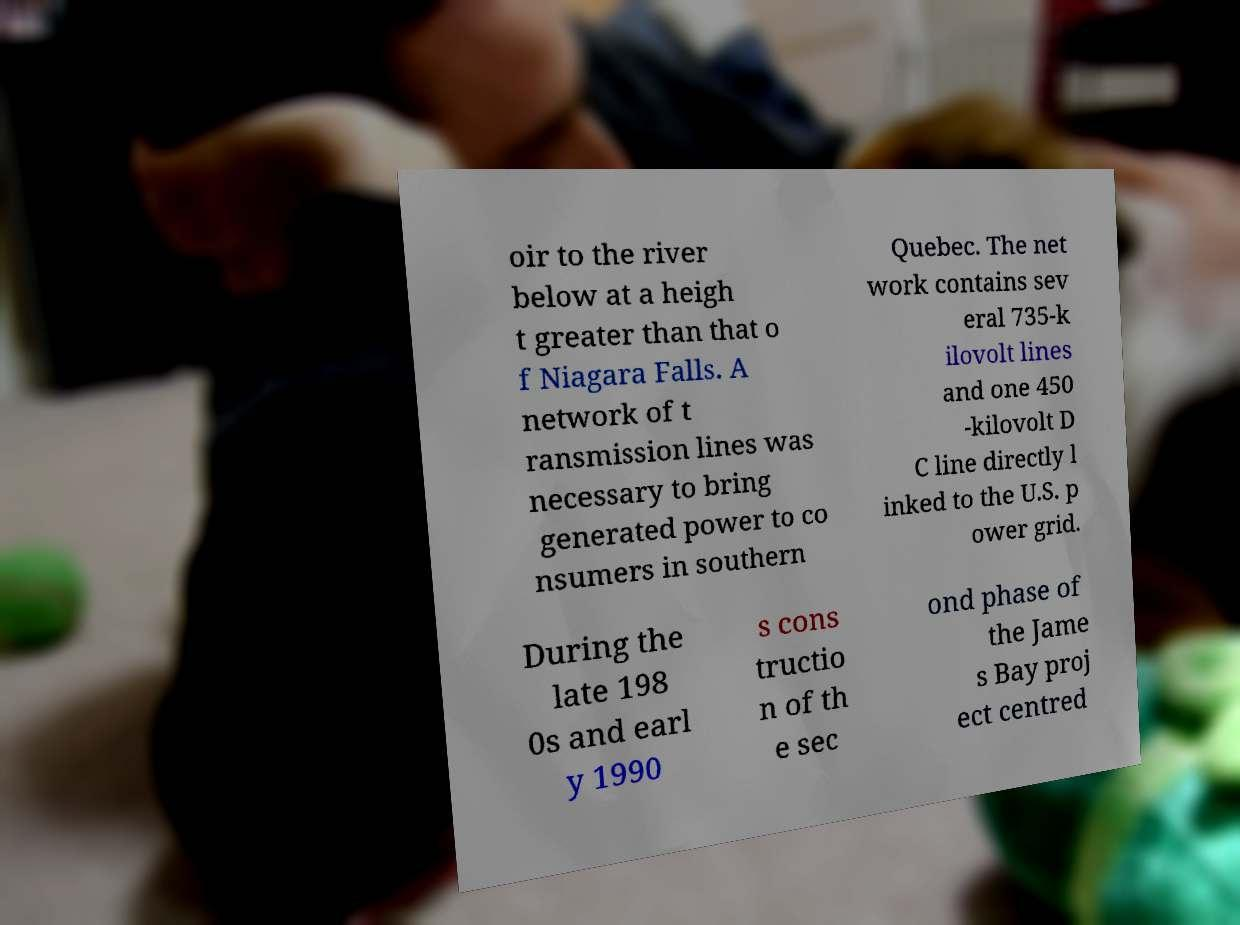Can you accurately transcribe the text from the provided image for me? oir to the river below at a heigh t greater than that o f Niagara Falls. A network of t ransmission lines was necessary to bring generated power to co nsumers in southern Quebec. The net work contains sev eral 735-k ilovolt lines and one 450 -kilovolt D C line directly l inked to the U.S. p ower grid. During the late 198 0s and earl y 1990 s cons tructio n of th e sec ond phase of the Jame s Bay proj ect centred 